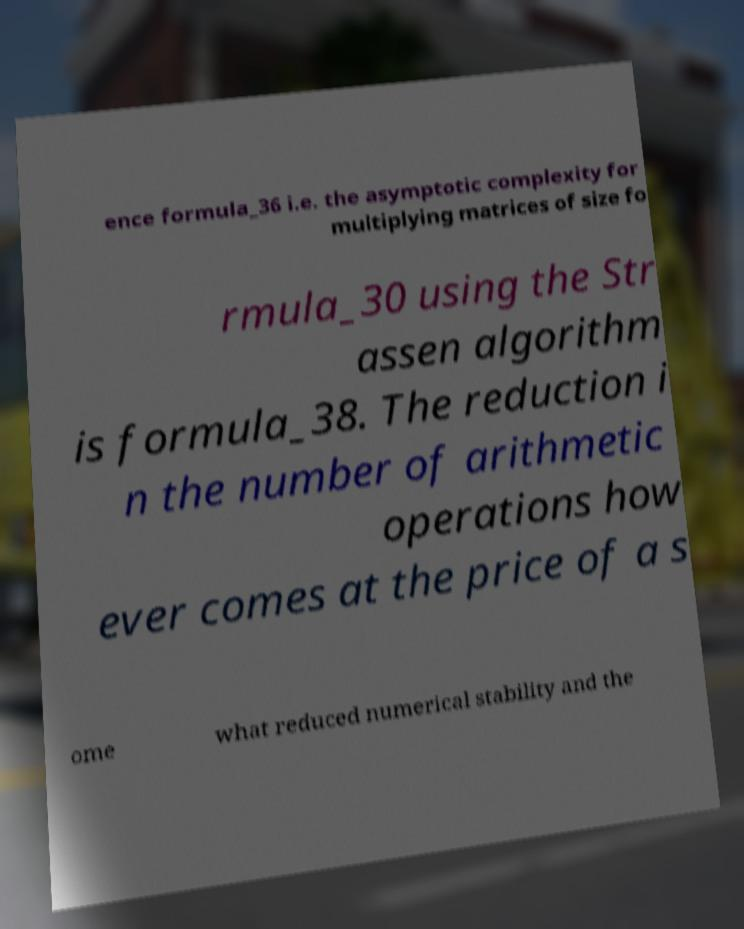I need the written content from this picture converted into text. Can you do that? ence formula_36 i.e. the asymptotic complexity for multiplying matrices of size fo rmula_30 using the Str assen algorithm is formula_38. The reduction i n the number of arithmetic operations how ever comes at the price of a s ome what reduced numerical stability and the 